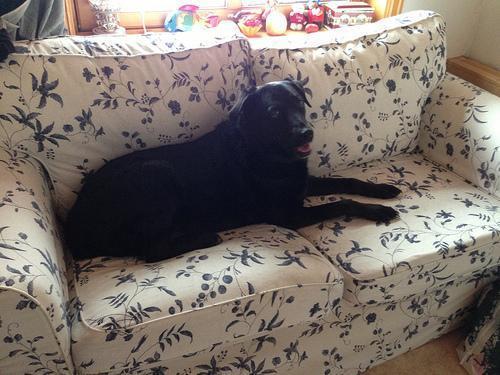How many dogs are there?
Give a very brief answer. 1. 